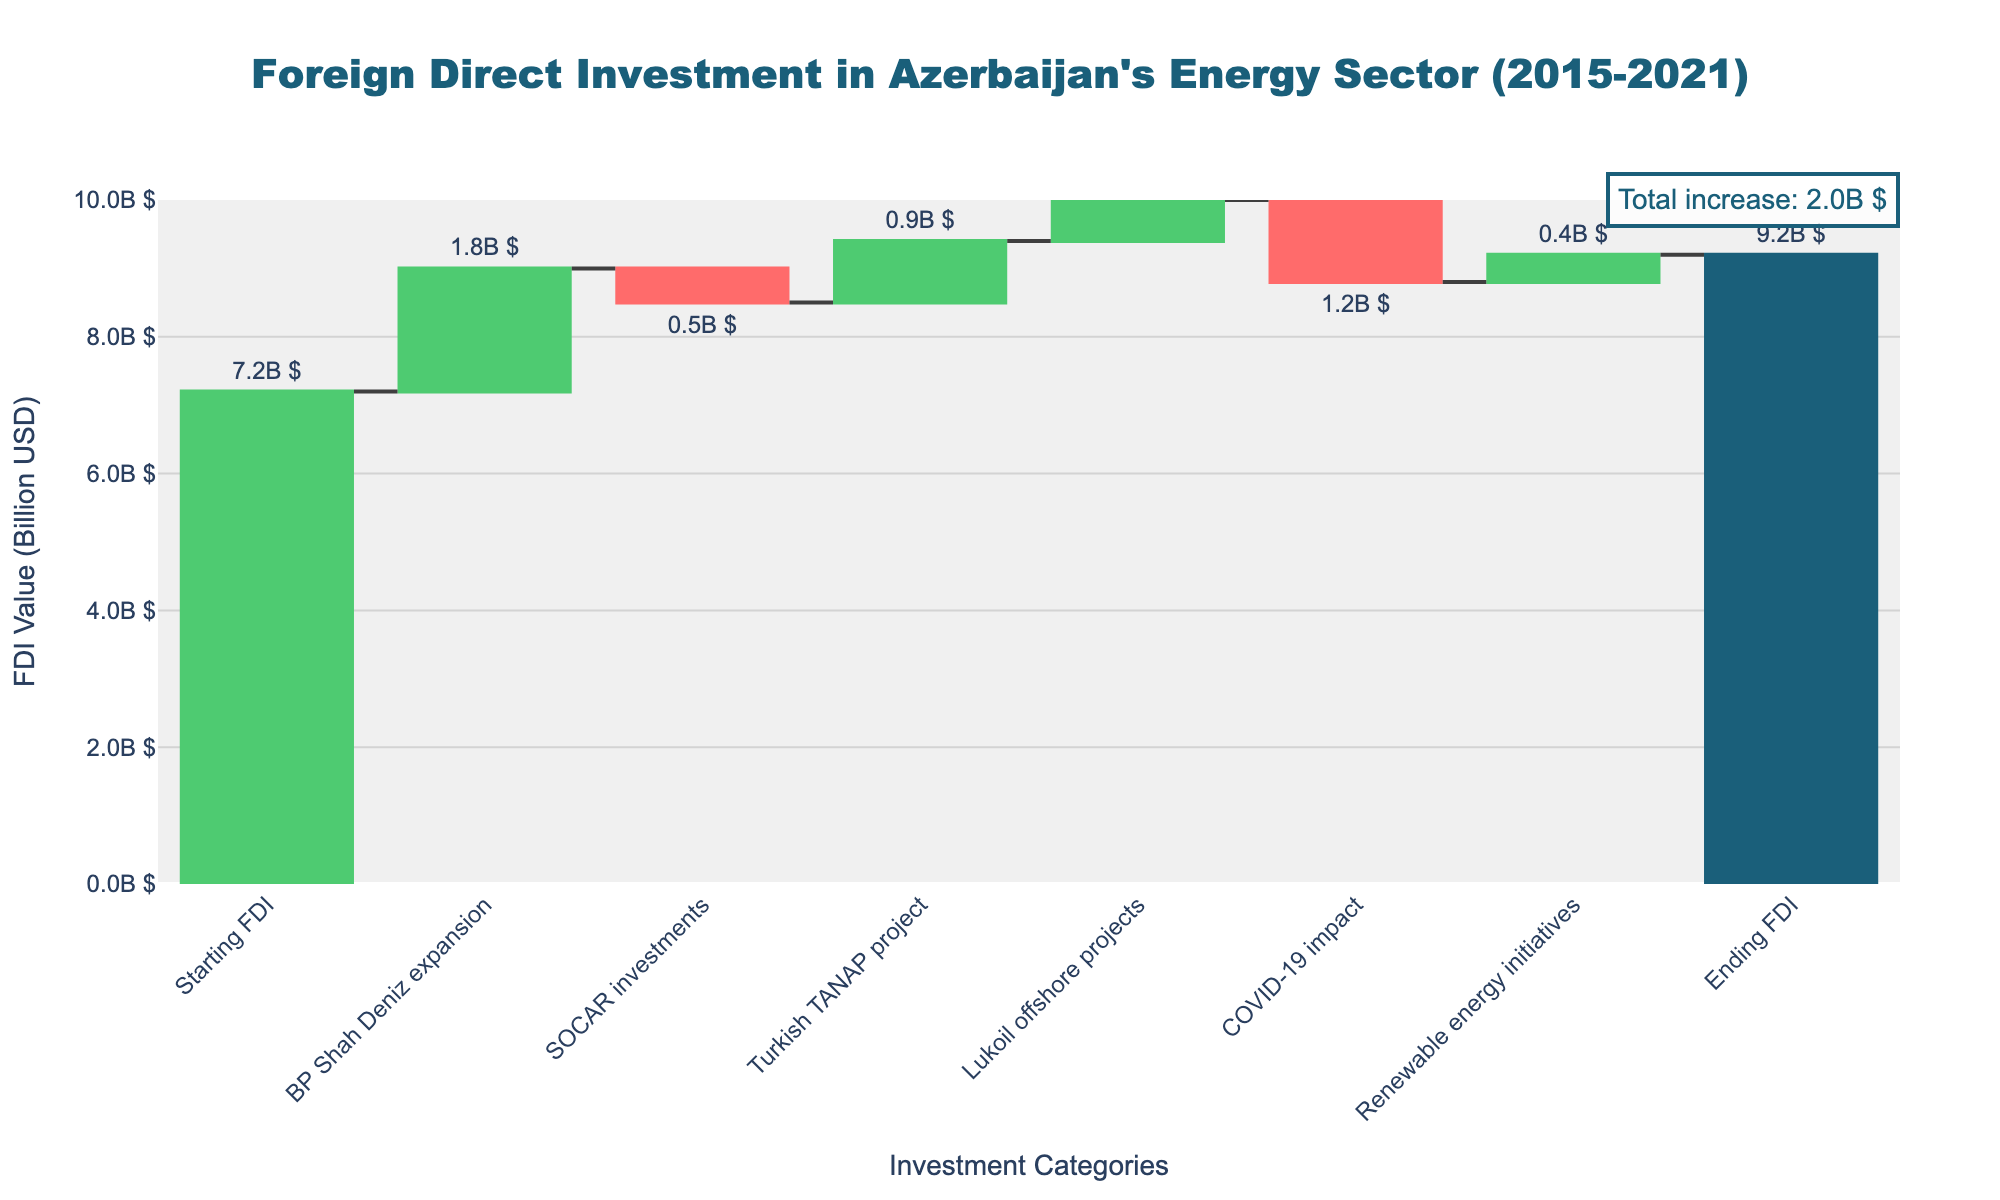What is the title of the chart? The title is usually found at the top of the chart. In this case, it reads "Foreign Direct Investment in Azerbaijan's Energy Sector (2015-2021)."
Answer: Foreign Direct Investment in Azerbaijan's Energy Sector (2015-2021) How many investment categories are listed in the chart? Count all unique categories listed on the x-axis of the chart. There are categories from 2015 to 2021, a total of 7 categories.
Answer: 7 What was the starting FDI value in 2015? The starting FDI value in 2015 can be found by looking at the bar labeled "Starting FDI" for 2015. The value is 7.2 billion USD.
Answer: 7.2 billion USD Which year experienced the highest positive FDI change? To determine the highest positive FDI change, observe each bar’s height and color. The "BP Shah Deniz expansion" in 2016, with a value of 1.8 billion USD, is the highest positive change.
Answer: 2016 Add the positive FDI changes for the years 2016 to 2021. What is the total? Sum up the FDI values for the positive changes from 2016 to 2021: BP Shah Deniz expansion (1.8), Turkish TANAP project (0.9), Lukoil offshore projects (0.6), and Renewable energy initiatives (0.4). \(1.8 + 0.9 + 0.6 + 0.4 = 3.7 \) billion USD.
Answer: 3.7 billion USD What was the impact of the COVID-19 pandemic on FDI in 2020? The impact of the pandemic is visible by the red bar for 2020 labeled "COVID-19 impact." It shows a negative value of -1.2 billion USD.
Answer: -1.2 billion USD Compare the FDI change due to SOCAR investments in 2017 with the FDI change due to COVID-19 in 2020. Which was more significant and by how much? Compare the absolute values of the negative contributions: SOCAR investments in 2017 (-0.5 billion USD) and COVID-19 in 2020 (-1.2 billion USD). The COVID-19 impact is more significant by \(1.2 - 0.5 = 0.7\) billion USD.
Answer: COVID-19 impact, by 0.7 billion USD What is the ending FDI value in 2021? The ending FDI value for 2021 is shown at the final bar of the chart labeled "Ending FDI." It reads 9.2 billion USD.
Answer: 9.2 billion USD What is the total increase in FDI from 2015 to 2021? The total increase in FDI from 2015 to 2021 can be calculated by subtracting the starting FDI (2015) from the ending FDI (2021). \(9.2 - 7.2 = 2 \) billion USD.
Answer: 2 billion USD 